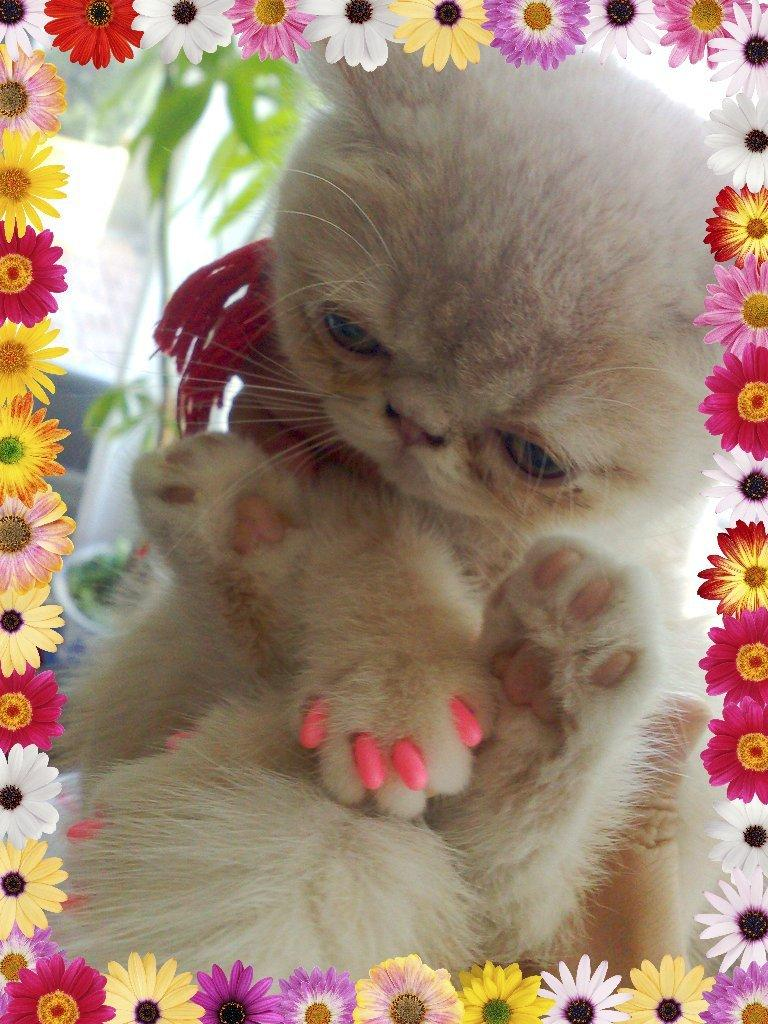What type of animal is in the image? There is a cat in the image. Can you describe the color of the cat? The cat is light brown in color. What other object can be seen in the image? There is a plant in the image. What else is present around the image? Flowers are present around the image. What type of cave can be seen in the image? There is no cave present in the image; it features a cat, a plant, and flowers. What type of cart is being used by the cat in the image? There is no cart present in the image, and the cat is not shown using any type of cart. 